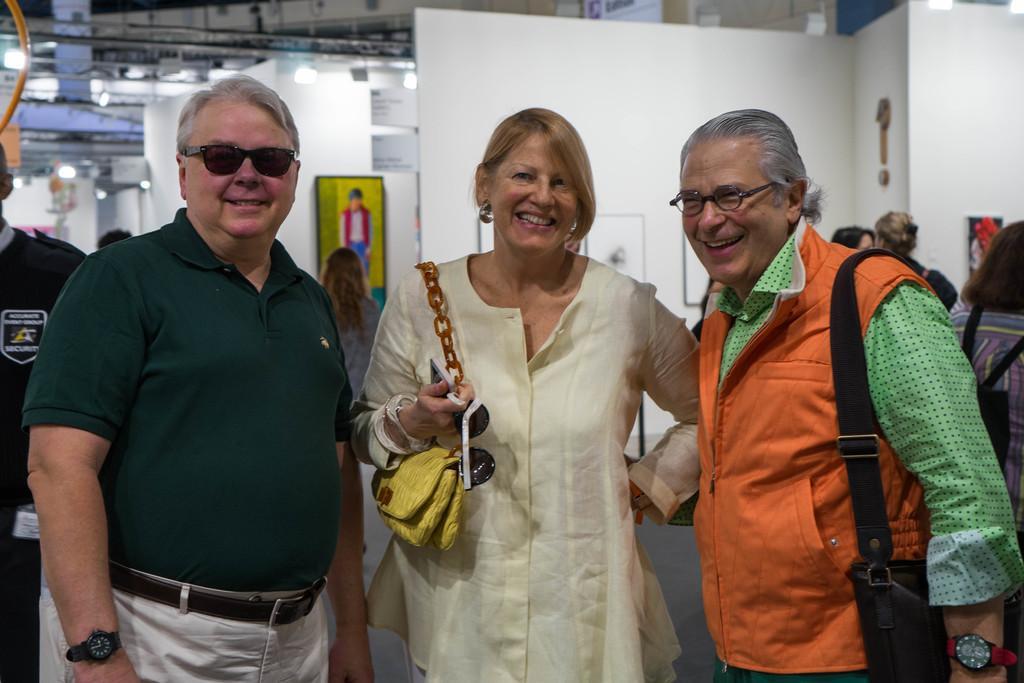In one or two sentences, can you explain what this image depicts? In this picture we can see three people and they are smiling and in the background we can see a group of people, lights and some objects. 